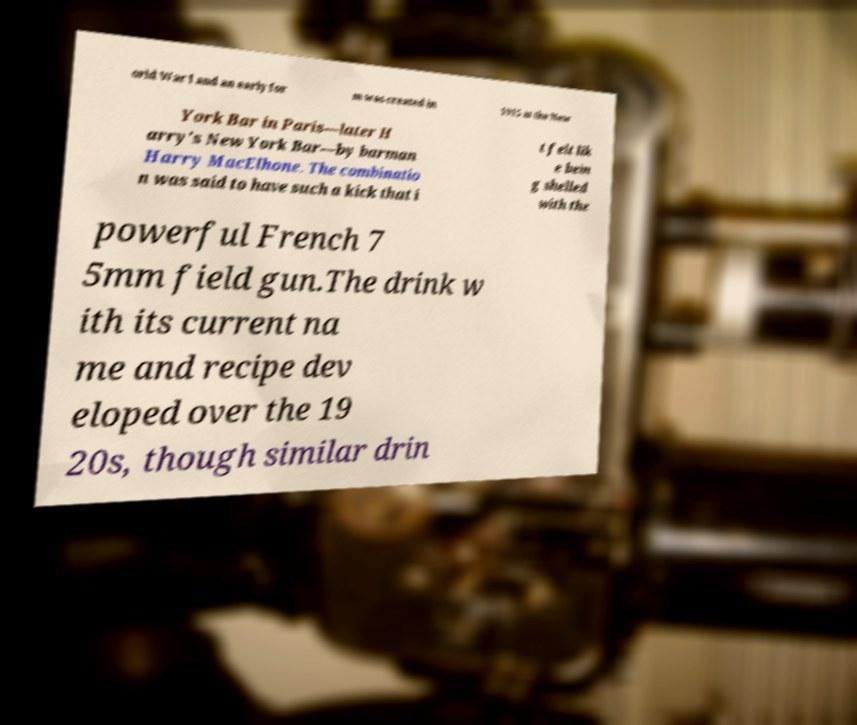Could you assist in decoding the text presented in this image and type it out clearly? orld War I and an early for m was created in 1915 at the New York Bar in Paris—later H arry's New York Bar—by barman Harry MacElhone. The combinatio n was said to have such a kick that i t felt lik e bein g shelled with the powerful French 7 5mm field gun.The drink w ith its current na me and recipe dev eloped over the 19 20s, though similar drin 